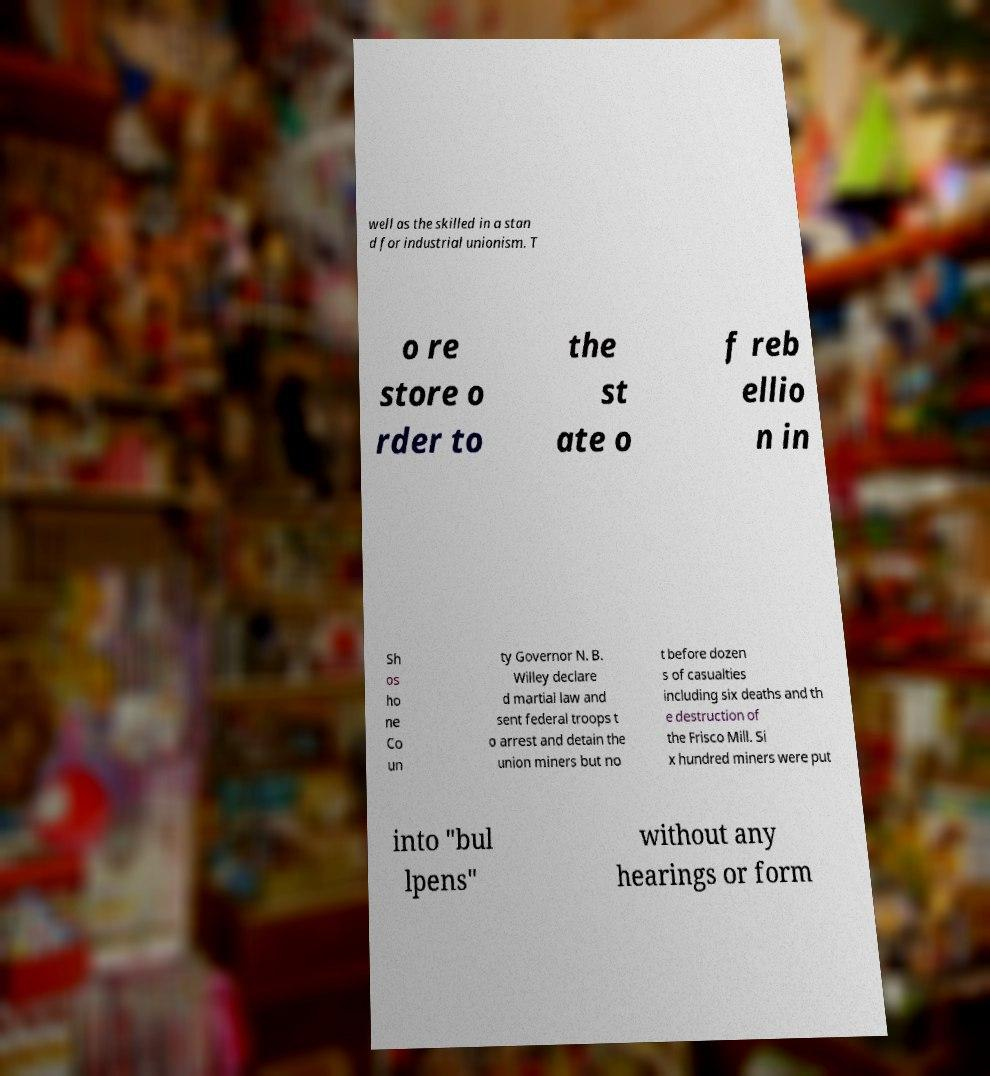For documentation purposes, I need the text within this image transcribed. Could you provide that? well as the skilled in a stan d for industrial unionism. T o re store o rder to the st ate o f reb ellio n in Sh os ho ne Co un ty Governor N. B. Willey declare d martial law and sent federal troops t o arrest and detain the union miners but no t before dozen s of casualties including six deaths and th e destruction of the Frisco Mill. Si x hundred miners were put into "bul lpens" without any hearings or form 